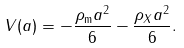Convert formula to latex. <formula><loc_0><loc_0><loc_500><loc_500>V ( a ) = - \frac { \rho _ { \text {m} } a ^ { 2 } } { 6 } - \frac { \rho _ { X } a ^ { 2 } } { 6 } .</formula> 